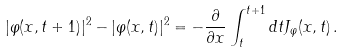<formula> <loc_0><loc_0><loc_500><loc_500>| \varphi ( x , t + 1 ) | ^ { 2 } - | \varphi ( x , t ) | ^ { 2 } = - \frac { \partial } { \partial x } \int _ { t } ^ { t + 1 } d t J _ { \varphi } ( x , t ) \, .</formula> 